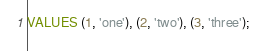Convert code to text. <code><loc_0><loc_0><loc_500><loc_500><_SQL_>VALUES (1, 'one'), (2, 'two'), (3, 'three');</code> 